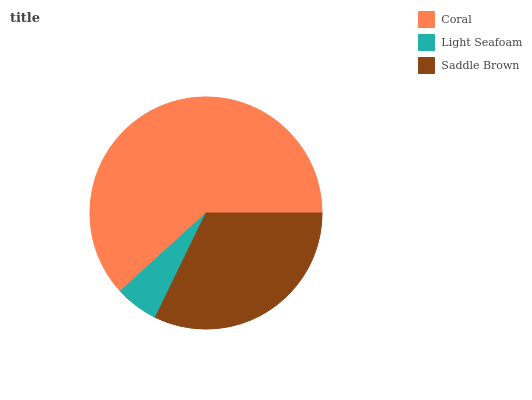Is Light Seafoam the minimum?
Answer yes or no. Yes. Is Coral the maximum?
Answer yes or no. Yes. Is Saddle Brown the minimum?
Answer yes or no. No. Is Saddle Brown the maximum?
Answer yes or no. No. Is Saddle Brown greater than Light Seafoam?
Answer yes or no. Yes. Is Light Seafoam less than Saddle Brown?
Answer yes or no. Yes. Is Light Seafoam greater than Saddle Brown?
Answer yes or no. No. Is Saddle Brown less than Light Seafoam?
Answer yes or no. No. Is Saddle Brown the high median?
Answer yes or no. Yes. Is Saddle Brown the low median?
Answer yes or no. Yes. Is Light Seafoam the high median?
Answer yes or no. No. Is Light Seafoam the low median?
Answer yes or no. No. 